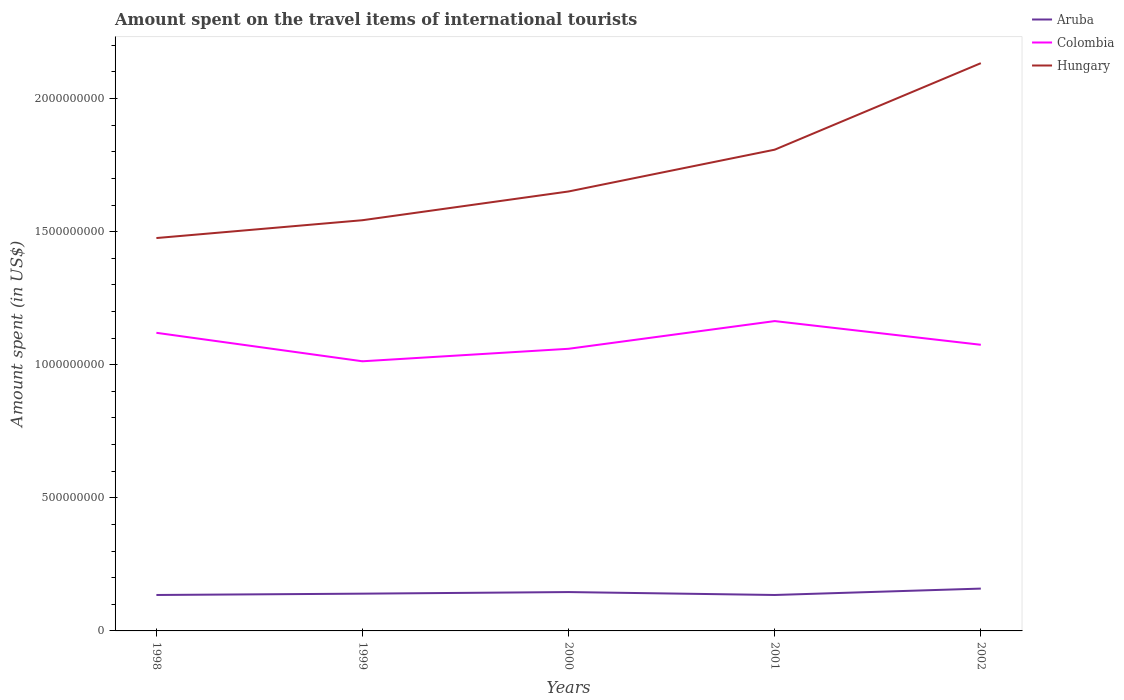Is the number of lines equal to the number of legend labels?
Provide a short and direct response. Yes. Across all years, what is the maximum amount spent on the travel items of international tourists in Aruba?
Your response must be concise. 1.35e+08. What is the total amount spent on the travel items of international tourists in Colombia in the graph?
Your answer should be very brief. 4.50e+07. What is the difference between the highest and the second highest amount spent on the travel items of international tourists in Colombia?
Make the answer very short. 1.51e+08. Is the amount spent on the travel items of international tourists in Aruba strictly greater than the amount spent on the travel items of international tourists in Hungary over the years?
Your response must be concise. Yes. What is the difference between two consecutive major ticks on the Y-axis?
Ensure brevity in your answer.  5.00e+08. Where does the legend appear in the graph?
Provide a succinct answer. Top right. How many legend labels are there?
Ensure brevity in your answer.  3. What is the title of the graph?
Make the answer very short. Amount spent on the travel items of international tourists. What is the label or title of the X-axis?
Your answer should be very brief. Years. What is the label or title of the Y-axis?
Your answer should be compact. Amount spent (in US$). What is the Amount spent (in US$) of Aruba in 1998?
Your response must be concise. 1.35e+08. What is the Amount spent (in US$) in Colombia in 1998?
Offer a very short reply. 1.12e+09. What is the Amount spent (in US$) in Hungary in 1998?
Offer a very short reply. 1.48e+09. What is the Amount spent (in US$) in Aruba in 1999?
Your answer should be compact. 1.40e+08. What is the Amount spent (in US$) in Colombia in 1999?
Make the answer very short. 1.01e+09. What is the Amount spent (in US$) in Hungary in 1999?
Your response must be concise. 1.54e+09. What is the Amount spent (in US$) in Aruba in 2000?
Keep it short and to the point. 1.46e+08. What is the Amount spent (in US$) of Colombia in 2000?
Offer a very short reply. 1.06e+09. What is the Amount spent (in US$) of Hungary in 2000?
Your response must be concise. 1.65e+09. What is the Amount spent (in US$) in Aruba in 2001?
Offer a terse response. 1.35e+08. What is the Amount spent (in US$) of Colombia in 2001?
Make the answer very short. 1.16e+09. What is the Amount spent (in US$) of Hungary in 2001?
Make the answer very short. 1.81e+09. What is the Amount spent (in US$) of Aruba in 2002?
Ensure brevity in your answer.  1.59e+08. What is the Amount spent (in US$) of Colombia in 2002?
Make the answer very short. 1.08e+09. What is the Amount spent (in US$) in Hungary in 2002?
Your response must be concise. 2.13e+09. Across all years, what is the maximum Amount spent (in US$) of Aruba?
Offer a terse response. 1.59e+08. Across all years, what is the maximum Amount spent (in US$) of Colombia?
Offer a terse response. 1.16e+09. Across all years, what is the maximum Amount spent (in US$) of Hungary?
Your answer should be compact. 2.13e+09. Across all years, what is the minimum Amount spent (in US$) of Aruba?
Your response must be concise. 1.35e+08. Across all years, what is the minimum Amount spent (in US$) in Colombia?
Your response must be concise. 1.01e+09. Across all years, what is the minimum Amount spent (in US$) in Hungary?
Ensure brevity in your answer.  1.48e+09. What is the total Amount spent (in US$) of Aruba in the graph?
Make the answer very short. 7.15e+08. What is the total Amount spent (in US$) of Colombia in the graph?
Give a very brief answer. 5.43e+09. What is the total Amount spent (in US$) in Hungary in the graph?
Make the answer very short. 8.61e+09. What is the difference between the Amount spent (in US$) of Aruba in 1998 and that in 1999?
Ensure brevity in your answer.  -5.00e+06. What is the difference between the Amount spent (in US$) in Colombia in 1998 and that in 1999?
Provide a succinct answer. 1.07e+08. What is the difference between the Amount spent (in US$) in Hungary in 1998 and that in 1999?
Offer a terse response. -6.70e+07. What is the difference between the Amount spent (in US$) of Aruba in 1998 and that in 2000?
Offer a very short reply. -1.10e+07. What is the difference between the Amount spent (in US$) of Colombia in 1998 and that in 2000?
Make the answer very short. 6.00e+07. What is the difference between the Amount spent (in US$) in Hungary in 1998 and that in 2000?
Provide a succinct answer. -1.75e+08. What is the difference between the Amount spent (in US$) of Colombia in 1998 and that in 2001?
Your response must be concise. -4.40e+07. What is the difference between the Amount spent (in US$) in Hungary in 1998 and that in 2001?
Provide a short and direct response. -3.32e+08. What is the difference between the Amount spent (in US$) in Aruba in 1998 and that in 2002?
Your answer should be compact. -2.40e+07. What is the difference between the Amount spent (in US$) in Colombia in 1998 and that in 2002?
Your response must be concise. 4.50e+07. What is the difference between the Amount spent (in US$) in Hungary in 1998 and that in 2002?
Ensure brevity in your answer.  -6.57e+08. What is the difference between the Amount spent (in US$) of Aruba in 1999 and that in 2000?
Your answer should be compact. -6.00e+06. What is the difference between the Amount spent (in US$) in Colombia in 1999 and that in 2000?
Provide a short and direct response. -4.70e+07. What is the difference between the Amount spent (in US$) in Hungary in 1999 and that in 2000?
Give a very brief answer. -1.08e+08. What is the difference between the Amount spent (in US$) of Aruba in 1999 and that in 2001?
Offer a terse response. 5.00e+06. What is the difference between the Amount spent (in US$) in Colombia in 1999 and that in 2001?
Your answer should be very brief. -1.51e+08. What is the difference between the Amount spent (in US$) in Hungary in 1999 and that in 2001?
Your answer should be very brief. -2.65e+08. What is the difference between the Amount spent (in US$) of Aruba in 1999 and that in 2002?
Offer a terse response. -1.90e+07. What is the difference between the Amount spent (in US$) in Colombia in 1999 and that in 2002?
Give a very brief answer. -6.20e+07. What is the difference between the Amount spent (in US$) of Hungary in 1999 and that in 2002?
Provide a succinct answer. -5.90e+08. What is the difference between the Amount spent (in US$) in Aruba in 2000 and that in 2001?
Give a very brief answer. 1.10e+07. What is the difference between the Amount spent (in US$) of Colombia in 2000 and that in 2001?
Make the answer very short. -1.04e+08. What is the difference between the Amount spent (in US$) of Hungary in 2000 and that in 2001?
Your response must be concise. -1.57e+08. What is the difference between the Amount spent (in US$) of Aruba in 2000 and that in 2002?
Make the answer very short. -1.30e+07. What is the difference between the Amount spent (in US$) in Colombia in 2000 and that in 2002?
Ensure brevity in your answer.  -1.50e+07. What is the difference between the Amount spent (in US$) in Hungary in 2000 and that in 2002?
Keep it short and to the point. -4.82e+08. What is the difference between the Amount spent (in US$) in Aruba in 2001 and that in 2002?
Offer a very short reply. -2.40e+07. What is the difference between the Amount spent (in US$) in Colombia in 2001 and that in 2002?
Your answer should be compact. 8.90e+07. What is the difference between the Amount spent (in US$) in Hungary in 2001 and that in 2002?
Make the answer very short. -3.25e+08. What is the difference between the Amount spent (in US$) of Aruba in 1998 and the Amount spent (in US$) of Colombia in 1999?
Offer a very short reply. -8.78e+08. What is the difference between the Amount spent (in US$) of Aruba in 1998 and the Amount spent (in US$) of Hungary in 1999?
Keep it short and to the point. -1.41e+09. What is the difference between the Amount spent (in US$) of Colombia in 1998 and the Amount spent (in US$) of Hungary in 1999?
Give a very brief answer. -4.23e+08. What is the difference between the Amount spent (in US$) of Aruba in 1998 and the Amount spent (in US$) of Colombia in 2000?
Ensure brevity in your answer.  -9.25e+08. What is the difference between the Amount spent (in US$) of Aruba in 1998 and the Amount spent (in US$) of Hungary in 2000?
Ensure brevity in your answer.  -1.52e+09. What is the difference between the Amount spent (in US$) of Colombia in 1998 and the Amount spent (in US$) of Hungary in 2000?
Offer a very short reply. -5.31e+08. What is the difference between the Amount spent (in US$) of Aruba in 1998 and the Amount spent (in US$) of Colombia in 2001?
Your answer should be very brief. -1.03e+09. What is the difference between the Amount spent (in US$) of Aruba in 1998 and the Amount spent (in US$) of Hungary in 2001?
Offer a very short reply. -1.67e+09. What is the difference between the Amount spent (in US$) in Colombia in 1998 and the Amount spent (in US$) in Hungary in 2001?
Offer a very short reply. -6.88e+08. What is the difference between the Amount spent (in US$) of Aruba in 1998 and the Amount spent (in US$) of Colombia in 2002?
Keep it short and to the point. -9.40e+08. What is the difference between the Amount spent (in US$) in Aruba in 1998 and the Amount spent (in US$) in Hungary in 2002?
Make the answer very short. -2.00e+09. What is the difference between the Amount spent (in US$) in Colombia in 1998 and the Amount spent (in US$) in Hungary in 2002?
Provide a succinct answer. -1.01e+09. What is the difference between the Amount spent (in US$) in Aruba in 1999 and the Amount spent (in US$) in Colombia in 2000?
Ensure brevity in your answer.  -9.20e+08. What is the difference between the Amount spent (in US$) in Aruba in 1999 and the Amount spent (in US$) in Hungary in 2000?
Offer a terse response. -1.51e+09. What is the difference between the Amount spent (in US$) in Colombia in 1999 and the Amount spent (in US$) in Hungary in 2000?
Give a very brief answer. -6.38e+08. What is the difference between the Amount spent (in US$) in Aruba in 1999 and the Amount spent (in US$) in Colombia in 2001?
Provide a short and direct response. -1.02e+09. What is the difference between the Amount spent (in US$) in Aruba in 1999 and the Amount spent (in US$) in Hungary in 2001?
Make the answer very short. -1.67e+09. What is the difference between the Amount spent (in US$) in Colombia in 1999 and the Amount spent (in US$) in Hungary in 2001?
Offer a terse response. -7.95e+08. What is the difference between the Amount spent (in US$) in Aruba in 1999 and the Amount spent (in US$) in Colombia in 2002?
Provide a short and direct response. -9.35e+08. What is the difference between the Amount spent (in US$) in Aruba in 1999 and the Amount spent (in US$) in Hungary in 2002?
Keep it short and to the point. -1.99e+09. What is the difference between the Amount spent (in US$) of Colombia in 1999 and the Amount spent (in US$) of Hungary in 2002?
Give a very brief answer. -1.12e+09. What is the difference between the Amount spent (in US$) in Aruba in 2000 and the Amount spent (in US$) in Colombia in 2001?
Keep it short and to the point. -1.02e+09. What is the difference between the Amount spent (in US$) of Aruba in 2000 and the Amount spent (in US$) of Hungary in 2001?
Make the answer very short. -1.66e+09. What is the difference between the Amount spent (in US$) of Colombia in 2000 and the Amount spent (in US$) of Hungary in 2001?
Offer a terse response. -7.48e+08. What is the difference between the Amount spent (in US$) of Aruba in 2000 and the Amount spent (in US$) of Colombia in 2002?
Provide a succinct answer. -9.29e+08. What is the difference between the Amount spent (in US$) of Aruba in 2000 and the Amount spent (in US$) of Hungary in 2002?
Keep it short and to the point. -1.99e+09. What is the difference between the Amount spent (in US$) of Colombia in 2000 and the Amount spent (in US$) of Hungary in 2002?
Your answer should be very brief. -1.07e+09. What is the difference between the Amount spent (in US$) of Aruba in 2001 and the Amount spent (in US$) of Colombia in 2002?
Provide a succinct answer. -9.40e+08. What is the difference between the Amount spent (in US$) of Aruba in 2001 and the Amount spent (in US$) of Hungary in 2002?
Ensure brevity in your answer.  -2.00e+09. What is the difference between the Amount spent (in US$) in Colombia in 2001 and the Amount spent (in US$) in Hungary in 2002?
Give a very brief answer. -9.69e+08. What is the average Amount spent (in US$) in Aruba per year?
Your answer should be compact. 1.43e+08. What is the average Amount spent (in US$) in Colombia per year?
Give a very brief answer. 1.09e+09. What is the average Amount spent (in US$) of Hungary per year?
Your response must be concise. 1.72e+09. In the year 1998, what is the difference between the Amount spent (in US$) in Aruba and Amount spent (in US$) in Colombia?
Keep it short and to the point. -9.85e+08. In the year 1998, what is the difference between the Amount spent (in US$) of Aruba and Amount spent (in US$) of Hungary?
Offer a terse response. -1.34e+09. In the year 1998, what is the difference between the Amount spent (in US$) in Colombia and Amount spent (in US$) in Hungary?
Your answer should be compact. -3.56e+08. In the year 1999, what is the difference between the Amount spent (in US$) in Aruba and Amount spent (in US$) in Colombia?
Your answer should be very brief. -8.73e+08. In the year 1999, what is the difference between the Amount spent (in US$) of Aruba and Amount spent (in US$) of Hungary?
Your answer should be compact. -1.40e+09. In the year 1999, what is the difference between the Amount spent (in US$) in Colombia and Amount spent (in US$) in Hungary?
Your answer should be compact. -5.30e+08. In the year 2000, what is the difference between the Amount spent (in US$) of Aruba and Amount spent (in US$) of Colombia?
Your response must be concise. -9.14e+08. In the year 2000, what is the difference between the Amount spent (in US$) in Aruba and Amount spent (in US$) in Hungary?
Keep it short and to the point. -1.50e+09. In the year 2000, what is the difference between the Amount spent (in US$) in Colombia and Amount spent (in US$) in Hungary?
Make the answer very short. -5.91e+08. In the year 2001, what is the difference between the Amount spent (in US$) in Aruba and Amount spent (in US$) in Colombia?
Provide a short and direct response. -1.03e+09. In the year 2001, what is the difference between the Amount spent (in US$) of Aruba and Amount spent (in US$) of Hungary?
Your response must be concise. -1.67e+09. In the year 2001, what is the difference between the Amount spent (in US$) in Colombia and Amount spent (in US$) in Hungary?
Your answer should be compact. -6.44e+08. In the year 2002, what is the difference between the Amount spent (in US$) in Aruba and Amount spent (in US$) in Colombia?
Make the answer very short. -9.16e+08. In the year 2002, what is the difference between the Amount spent (in US$) in Aruba and Amount spent (in US$) in Hungary?
Give a very brief answer. -1.97e+09. In the year 2002, what is the difference between the Amount spent (in US$) in Colombia and Amount spent (in US$) in Hungary?
Give a very brief answer. -1.06e+09. What is the ratio of the Amount spent (in US$) of Colombia in 1998 to that in 1999?
Provide a short and direct response. 1.11. What is the ratio of the Amount spent (in US$) of Hungary in 1998 to that in 1999?
Offer a very short reply. 0.96. What is the ratio of the Amount spent (in US$) in Aruba in 1998 to that in 2000?
Your answer should be compact. 0.92. What is the ratio of the Amount spent (in US$) in Colombia in 1998 to that in 2000?
Your response must be concise. 1.06. What is the ratio of the Amount spent (in US$) in Hungary in 1998 to that in 2000?
Offer a terse response. 0.89. What is the ratio of the Amount spent (in US$) in Aruba in 1998 to that in 2001?
Provide a succinct answer. 1. What is the ratio of the Amount spent (in US$) of Colombia in 1998 to that in 2001?
Provide a short and direct response. 0.96. What is the ratio of the Amount spent (in US$) in Hungary in 1998 to that in 2001?
Make the answer very short. 0.82. What is the ratio of the Amount spent (in US$) in Aruba in 1998 to that in 2002?
Provide a succinct answer. 0.85. What is the ratio of the Amount spent (in US$) of Colombia in 1998 to that in 2002?
Ensure brevity in your answer.  1.04. What is the ratio of the Amount spent (in US$) in Hungary in 1998 to that in 2002?
Ensure brevity in your answer.  0.69. What is the ratio of the Amount spent (in US$) in Aruba in 1999 to that in 2000?
Make the answer very short. 0.96. What is the ratio of the Amount spent (in US$) of Colombia in 1999 to that in 2000?
Your response must be concise. 0.96. What is the ratio of the Amount spent (in US$) in Hungary in 1999 to that in 2000?
Your response must be concise. 0.93. What is the ratio of the Amount spent (in US$) in Aruba in 1999 to that in 2001?
Offer a terse response. 1.04. What is the ratio of the Amount spent (in US$) in Colombia in 1999 to that in 2001?
Ensure brevity in your answer.  0.87. What is the ratio of the Amount spent (in US$) in Hungary in 1999 to that in 2001?
Give a very brief answer. 0.85. What is the ratio of the Amount spent (in US$) in Aruba in 1999 to that in 2002?
Keep it short and to the point. 0.88. What is the ratio of the Amount spent (in US$) in Colombia in 1999 to that in 2002?
Provide a succinct answer. 0.94. What is the ratio of the Amount spent (in US$) of Hungary in 1999 to that in 2002?
Your response must be concise. 0.72. What is the ratio of the Amount spent (in US$) in Aruba in 2000 to that in 2001?
Your answer should be very brief. 1.08. What is the ratio of the Amount spent (in US$) in Colombia in 2000 to that in 2001?
Your answer should be very brief. 0.91. What is the ratio of the Amount spent (in US$) of Hungary in 2000 to that in 2001?
Your answer should be compact. 0.91. What is the ratio of the Amount spent (in US$) in Aruba in 2000 to that in 2002?
Offer a terse response. 0.92. What is the ratio of the Amount spent (in US$) in Hungary in 2000 to that in 2002?
Offer a terse response. 0.77. What is the ratio of the Amount spent (in US$) of Aruba in 2001 to that in 2002?
Provide a short and direct response. 0.85. What is the ratio of the Amount spent (in US$) of Colombia in 2001 to that in 2002?
Offer a terse response. 1.08. What is the ratio of the Amount spent (in US$) in Hungary in 2001 to that in 2002?
Keep it short and to the point. 0.85. What is the difference between the highest and the second highest Amount spent (in US$) in Aruba?
Ensure brevity in your answer.  1.30e+07. What is the difference between the highest and the second highest Amount spent (in US$) of Colombia?
Keep it short and to the point. 4.40e+07. What is the difference between the highest and the second highest Amount spent (in US$) in Hungary?
Provide a short and direct response. 3.25e+08. What is the difference between the highest and the lowest Amount spent (in US$) of Aruba?
Your answer should be very brief. 2.40e+07. What is the difference between the highest and the lowest Amount spent (in US$) of Colombia?
Offer a terse response. 1.51e+08. What is the difference between the highest and the lowest Amount spent (in US$) in Hungary?
Provide a short and direct response. 6.57e+08. 